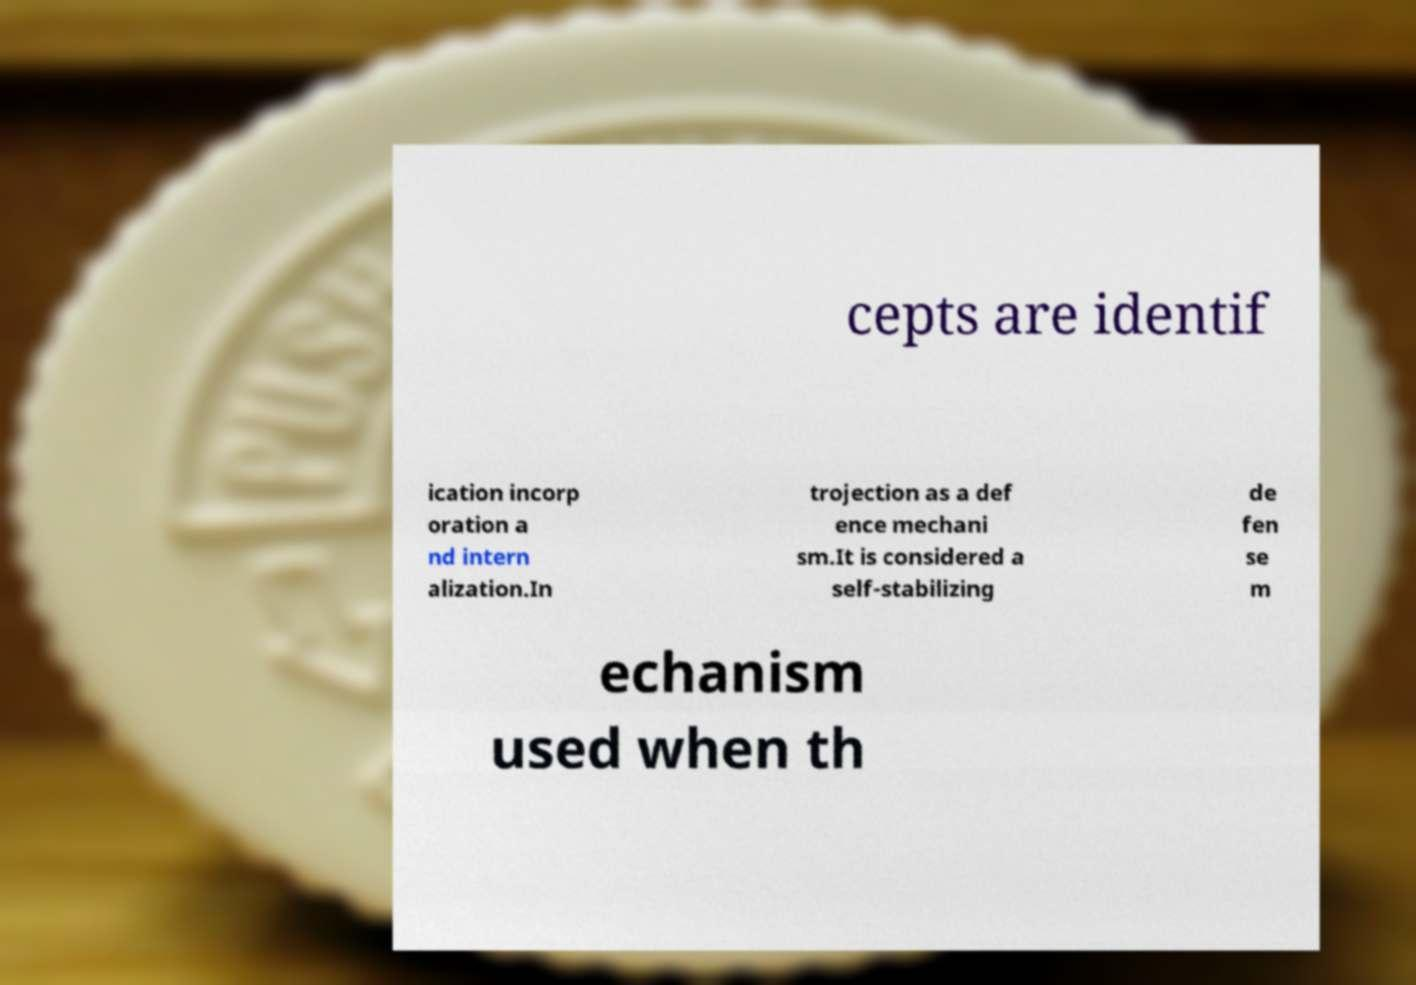Could you assist in decoding the text presented in this image and type it out clearly? cepts are identif ication incorp oration a nd intern alization.In trojection as a def ence mechani sm.It is considered a self-stabilizing de fen se m echanism used when th 